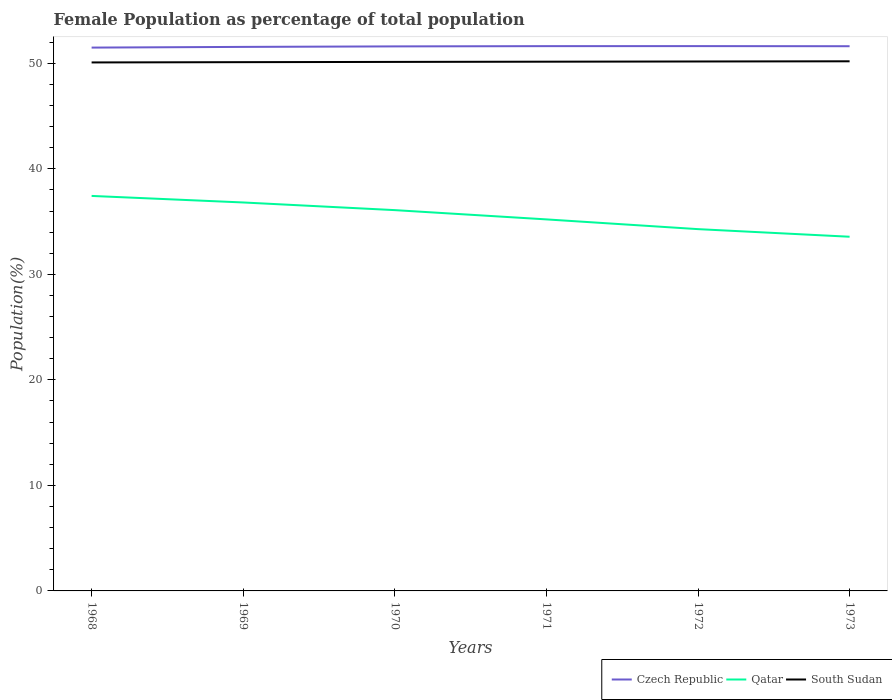Is the number of lines equal to the number of legend labels?
Provide a short and direct response. Yes. Across all years, what is the maximum female population in in South Sudan?
Your answer should be very brief. 50.08. In which year was the female population in in Qatar maximum?
Your response must be concise. 1973. What is the total female population in in Czech Republic in the graph?
Give a very brief answer. -0.07. What is the difference between the highest and the second highest female population in in South Sudan?
Ensure brevity in your answer.  0.11. How many years are there in the graph?
Offer a very short reply. 6. What is the difference between two consecutive major ticks on the Y-axis?
Keep it short and to the point. 10. Does the graph contain grids?
Your answer should be very brief. No. How many legend labels are there?
Make the answer very short. 3. How are the legend labels stacked?
Your response must be concise. Horizontal. What is the title of the graph?
Keep it short and to the point. Female Population as percentage of total population. Does "Ghana" appear as one of the legend labels in the graph?
Provide a short and direct response. No. What is the label or title of the X-axis?
Ensure brevity in your answer.  Years. What is the label or title of the Y-axis?
Offer a terse response. Population(%). What is the Population(%) of Czech Republic in 1968?
Ensure brevity in your answer.  51.49. What is the Population(%) in Qatar in 1968?
Give a very brief answer. 37.43. What is the Population(%) of South Sudan in 1968?
Ensure brevity in your answer.  50.08. What is the Population(%) in Czech Republic in 1969?
Give a very brief answer. 51.55. What is the Population(%) in Qatar in 1969?
Give a very brief answer. 36.81. What is the Population(%) of South Sudan in 1969?
Your answer should be very brief. 50.11. What is the Population(%) in Czech Republic in 1970?
Give a very brief answer. 51.6. What is the Population(%) of Qatar in 1970?
Keep it short and to the point. 36.09. What is the Population(%) of South Sudan in 1970?
Your answer should be compact. 50.13. What is the Population(%) in Czech Republic in 1971?
Give a very brief answer. 51.62. What is the Population(%) of Qatar in 1971?
Offer a terse response. 35.21. What is the Population(%) of South Sudan in 1971?
Your answer should be very brief. 50.15. What is the Population(%) of Czech Republic in 1972?
Keep it short and to the point. 51.63. What is the Population(%) of Qatar in 1972?
Provide a short and direct response. 34.28. What is the Population(%) of South Sudan in 1972?
Your answer should be very brief. 50.17. What is the Population(%) of Czech Republic in 1973?
Your answer should be very brief. 51.62. What is the Population(%) in Qatar in 1973?
Your answer should be compact. 33.56. What is the Population(%) of South Sudan in 1973?
Ensure brevity in your answer.  50.19. Across all years, what is the maximum Population(%) in Czech Republic?
Your answer should be very brief. 51.63. Across all years, what is the maximum Population(%) in Qatar?
Provide a succinct answer. 37.43. Across all years, what is the maximum Population(%) in South Sudan?
Provide a short and direct response. 50.19. Across all years, what is the minimum Population(%) of Czech Republic?
Give a very brief answer. 51.49. Across all years, what is the minimum Population(%) of Qatar?
Provide a succinct answer. 33.56. Across all years, what is the minimum Population(%) in South Sudan?
Give a very brief answer. 50.08. What is the total Population(%) in Czech Republic in the graph?
Offer a terse response. 309.52. What is the total Population(%) in Qatar in the graph?
Make the answer very short. 213.38. What is the total Population(%) of South Sudan in the graph?
Provide a short and direct response. 300.83. What is the difference between the Population(%) of Czech Republic in 1968 and that in 1969?
Ensure brevity in your answer.  -0.07. What is the difference between the Population(%) in Qatar in 1968 and that in 1969?
Offer a terse response. 0.62. What is the difference between the Population(%) of South Sudan in 1968 and that in 1969?
Offer a terse response. -0.03. What is the difference between the Population(%) of Czech Republic in 1968 and that in 1970?
Provide a succinct answer. -0.11. What is the difference between the Population(%) of Qatar in 1968 and that in 1970?
Provide a short and direct response. 1.35. What is the difference between the Population(%) of South Sudan in 1968 and that in 1970?
Your answer should be compact. -0.05. What is the difference between the Population(%) of Czech Republic in 1968 and that in 1971?
Provide a succinct answer. -0.14. What is the difference between the Population(%) in Qatar in 1968 and that in 1971?
Give a very brief answer. 2.22. What is the difference between the Population(%) of South Sudan in 1968 and that in 1971?
Keep it short and to the point. -0.07. What is the difference between the Population(%) of Czech Republic in 1968 and that in 1972?
Ensure brevity in your answer.  -0.14. What is the difference between the Population(%) of Qatar in 1968 and that in 1972?
Your answer should be very brief. 3.15. What is the difference between the Population(%) of South Sudan in 1968 and that in 1972?
Your answer should be compact. -0.09. What is the difference between the Population(%) in Czech Republic in 1968 and that in 1973?
Your response must be concise. -0.13. What is the difference between the Population(%) in Qatar in 1968 and that in 1973?
Your answer should be compact. 3.87. What is the difference between the Population(%) in South Sudan in 1968 and that in 1973?
Keep it short and to the point. -0.11. What is the difference between the Population(%) of Czech Republic in 1969 and that in 1970?
Your answer should be compact. -0.05. What is the difference between the Population(%) in Qatar in 1969 and that in 1970?
Ensure brevity in your answer.  0.73. What is the difference between the Population(%) of South Sudan in 1969 and that in 1970?
Offer a terse response. -0.02. What is the difference between the Population(%) of Czech Republic in 1969 and that in 1971?
Offer a terse response. -0.07. What is the difference between the Population(%) in Qatar in 1969 and that in 1971?
Offer a terse response. 1.6. What is the difference between the Population(%) of South Sudan in 1969 and that in 1971?
Offer a terse response. -0.04. What is the difference between the Population(%) in Czech Republic in 1969 and that in 1972?
Your answer should be very brief. -0.07. What is the difference between the Population(%) of Qatar in 1969 and that in 1972?
Offer a very short reply. 2.53. What is the difference between the Population(%) of South Sudan in 1969 and that in 1972?
Your response must be concise. -0.06. What is the difference between the Population(%) in Czech Republic in 1969 and that in 1973?
Provide a succinct answer. -0.06. What is the difference between the Population(%) in Qatar in 1969 and that in 1973?
Give a very brief answer. 3.25. What is the difference between the Population(%) in South Sudan in 1969 and that in 1973?
Your response must be concise. -0.08. What is the difference between the Population(%) of Czech Republic in 1970 and that in 1971?
Offer a very short reply. -0.02. What is the difference between the Population(%) in Qatar in 1970 and that in 1971?
Keep it short and to the point. 0.88. What is the difference between the Population(%) in South Sudan in 1970 and that in 1971?
Offer a terse response. -0.02. What is the difference between the Population(%) of Czech Republic in 1970 and that in 1972?
Your answer should be very brief. -0.03. What is the difference between the Population(%) in Qatar in 1970 and that in 1972?
Make the answer very short. 1.8. What is the difference between the Population(%) in South Sudan in 1970 and that in 1972?
Keep it short and to the point. -0.04. What is the difference between the Population(%) in Czech Republic in 1970 and that in 1973?
Give a very brief answer. -0.02. What is the difference between the Population(%) of Qatar in 1970 and that in 1973?
Offer a terse response. 2.52. What is the difference between the Population(%) in South Sudan in 1970 and that in 1973?
Keep it short and to the point. -0.06. What is the difference between the Population(%) of Czech Republic in 1971 and that in 1972?
Offer a very short reply. -0. What is the difference between the Population(%) in Qatar in 1971 and that in 1972?
Make the answer very short. 0.92. What is the difference between the Population(%) of South Sudan in 1971 and that in 1972?
Offer a terse response. -0.02. What is the difference between the Population(%) in Czech Republic in 1971 and that in 1973?
Your answer should be very brief. 0.01. What is the difference between the Population(%) of Qatar in 1971 and that in 1973?
Offer a very short reply. 1.64. What is the difference between the Population(%) of South Sudan in 1971 and that in 1973?
Provide a short and direct response. -0.04. What is the difference between the Population(%) in Czech Republic in 1972 and that in 1973?
Provide a short and direct response. 0.01. What is the difference between the Population(%) of Qatar in 1972 and that in 1973?
Offer a very short reply. 0.72. What is the difference between the Population(%) in South Sudan in 1972 and that in 1973?
Give a very brief answer. -0.02. What is the difference between the Population(%) of Czech Republic in 1968 and the Population(%) of Qatar in 1969?
Your answer should be very brief. 14.68. What is the difference between the Population(%) in Czech Republic in 1968 and the Population(%) in South Sudan in 1969?
Provide a succinct answer. 1.38. What is the difference between the Population(%) of Qatar in 1968 and the Population(%) of South Sudan in 1969?
Make the answer very short. -12.68. What is the difference between the Population(%) of Czech Republic in 1968 and the Population(%) of Qatar in 1970?
Your response must be concise. 15.4. What is the difference between the Population(%) of Czech Republic in 1968 and the Population(%) of South Sudan in 1970?
Keep it short and to the point. 1.36. What is the difference between the Population(%) of Czech Republic in 1968 and the Population(%) of Qatar in 1971?
Your answer should be very brief. 16.28. What is the difference between the Population(%) of Czech Republic in 1968 and the Population(%) of South Sudan in 1971?
Provide a succinct answer. 1.34. What is the difference between the Population(%) in Qatar in 1968 and the Population(%) in South Sudan in 1971?
Provide a short and direct response. -12.72. What is the difference between the Population(%) in Czech Republic in 1968 and the Population(%) in Qatar in 1972?
Ensure brevity in your answer.  17.2. What is the difference between the Population(%) in Czech Republic in 1968 and the Population(%) in South Sudan in 1972?
Ensure brevity in your answer.  1.32. What is the difference between the Population(%) in Qatar in 1968 and the Population(%) in South Sudan in 1972?
Make the answer very short. -12.74. What is the difference between the Population(%) in Czech Republic in 1968 and the Population(%) in Qatar in 1973?
Make the answer very short. 17.92. What is the difference between the Population(%) in Czech Republic in 1968 and the Population(%) in South Sudan in 1973?
Ensure brevity in your answer.  1.3. What is the difference between the Population(%) in Qatar in 1968 and the Population(%) in South Sudan in 1973?
Provide a short and direct response. -12.76. What is the difference between the Population(%) of Czech Republic in 1969 and the Population(%) of Qatar in 1970?
Your response must be concise. 15.47. What is the difference between the Population(%) of Czech Republic in 1969 and the Population(%) of South Sudan in 1970?
Give a very brief answer. 1.42. What is the difference between the Population(%) of Qatar in 1969 and the Population(%) of South Sudan in 1970?
Ensure brevity in your answer.  -13.32. What is the difference between the Population(%) of Czech Republic in 1969 and the Population(%) of Qatar in 1971?
Your answer should be very brief. 16.35. What is the difference between the Population(%) in Czech Republic in 1969 and the Population(%) in South Sudan in 1971?
Provide a succinct answer. 1.4. What is the difference between the Population(%) in Qatar in 1969 and the Population(%) in South Sudan in 1971?
Your answer should be very brief. -13.34. What is the difference between the Population(%) of Czech Republic in 1969 and the Population(%) of Qatar in 1972?
Provide a succinct answer. 17.27. What is the difference between the Population(%) in Czech Republic in 1969 and the Population(%) in South Sudan in 1972?
Provide a short and direct response. 1.38. What is the difference between the Population(%) of Qatar in 1969 and the Population(%) of South Sudan in 1972?
Your response must be concise. -13.36. What is the difference between the Population(%) of Czech Republic in 1969 and the Population(%) of Qatar in 1973?
Provide a succinct answer. 17.99. What is the difference between the Population(%) in Czech Republic in 1969 and the Population(%) in South Sudan in 1973?
Your answer should be compact. 1.37. What is the difference between the Population(%) of Qatar in 1969 and the Population(%) of South Sudan in 1973?
Your answer should be compact. -13.38. What is the difference between the Population(%) in Czech Republic in 1970 and the Population(%) in Qatar in 1971?
Your response must be concise. 16.39. What is the difference between the Population(%) in Czech Republic in 1970 and the Population(%) in South Sudan in 1971?
Make the answer very short. 1.45. What is the difference between the Population(%) of Qatar in 1970 and the Population(%) of South Sudan in 1971?
Provide a succinct answer. -14.07. What is the difference between the Population(%) in Czech Republic in 1970 and the Population(%) in Qatar in 1972?
Your answer should be compact. 17.32. What is the difference between the Population(%) in Czech Republic in 1970 and the Population(%) in South Sudan in 1972?
Make the answer very short. 1.43. What is the difference between the Population(%) in Qatar in 1970 and the Population(%) in South Sudan in 1972?
Make the answer very short. -14.09. What is the difference between the Population(%) of Czech Republic in 1970 and the Population(%) of Qatar in 1973?
Offer a very short reply. 18.04. What is the difference between the Population(%) in Czech Republic in 1970 and the Population(%) in South Sudan in 1973?
Make the answer very short. 1.41. What is the difference between the Population(%) in Qatar in 1970 and the Population(%) in South Sudan in 1973?
Your response must be concise. -14.1. What is the difference between the Population(%) in Czech Republic in 1971 and the Population(%) in Qatar in 1972?
Provide a succinct answer. 17.34. What is the difference between the Population(%) of Czech Republic in 1971 and the Population(%) of South Sudan in 1972?
Your answer should be very brief. 1.45. What is the difference between the Population(%) in Qatar in 1971 and the Population(%) in South Sudan in 1972?
Your answer should be very brief. -14.96. What is the difference between the Population(%) of Czech Republic in 1971 and the Population(%) of Qatar in 1973?
Offer a very short reply. 18.06. What is the difference between the Population(%) in Czech Republic in 1971 and the Population(%) in South Sudan in 1973?
Keep it short and to the point. 1.44. What is the difference between the Population(%) of Qatar in 1971 and the Population(%) of South Sudan in 1973?
Your answer should be compact. -14.98. What is the difference between the Population(%) of Czech Republic in 1972 and the Population(%) of Qatar in 1973?
Offer a terse response. 18.06. What is the difference between the Population(%) in Czech Republic in 1972 and the Population(%) in South Sudan in 1973?
Your answer should be very brief. 1.44. What is the difference between the Population(%) in Qatar in 1972 and the Population(%) in South Sudan in 1973?
Your answer should be very brief. -15.9. What is the average Population(%) of Czech Republic per year?
Provide a short and direct response. 51.59. What is the average Population(%) of Qatar per year?
Your answer should be compact. 35.56. What is the average Population(%) of South Sudan per year?
Ensure brevity in your answer.  50.14. In the year 1968, what is the difference between the Population(%) of Czech Republic and Population(%) of Qatar?
Offer a terse response. 14.06. In the year 1968, what is the difference between the Population(%) in Czech Republic and Population(%) in South Sudan?
Keep it short and to the point. 1.41. In the year 1968, what is the difference between the Population(%) of Qatar and Population(%) of South Sudan?
Your answer should be very brief. -12.65. In the year 1969, what is the difference between the Population(%) of Czech Republic and Population(%) of Qatar?
Make the answer very short. 14.74. In the year 1969, what is the difference between the Population(%) in Czech Republic and Population(%) in South Sudan?
Make the answer very short. 1.45. In the year 1969, what is the difference between the Population(%) of Qatar and Population(%) of South Sudan?
Offer a terse response. -13.3. In the year 1970, what is the difference between the Population(%) in Czech Republic and Population(%) in Qatar?
Offer a terse response. 15.52. In the year 1970, what is the difference between the Population(%) of Czech Republic and Population(%) of South Sudan?
Your response must be concise. 1.47. In the year 1970, what is the difference between the Population(%) of Qatar and Population(%) of South Sudan?
Your answer should be compact. -14.05. In the year 1971, what is the difference between the Population(%) of Czech Republic and Population(%) of Qatar?
Provide a succinct answer. 16.42. In the year 1971, what is the difference between the Population(%) in Czech Republic and Population(%) in South Sudan?
Provide a short and direct response. 1.47. In the year 1971, what is the difference between the Population(%) in Qatar and Population(%) in South Sudan?
Provide a succinct answer. -14.95. In the year 1972, what is the difference between the Population(%) in Czech Republic and Population(%) in Qatar?
Offer a terse response. 17.34. In the year 1972, what is the difference between the Population(%) of Czech Republic and Population(%) of South Sudan?
Your answer should be compact. 1.46. In the year 1972, what is the difference between the Population(%) of Qatar and Population(%) of South Sudan?
Ensure brevity in your answer.  -15.89. In the year 1973, what is the difference between the Population(%) of Czech Republic and Population(%) of Qatar?
Give a very brief answer. 18.05. In the year 1973, what is the difference between the Population(%) of Czech Republic and Population(%) of South Sudan?
Offer a very short reply. 1.43. In the year 1973, what is the difference between the Population(%) of Qatar and Population(%) of South Sudan?
Your response must be concise. -16.62. What is the ratio of the Population(%) of Czech Republic in 1968 to that in 1969?
Make the answer very short. 1. What is the ratio of the Population(%) in Qatar in 1968 to that in 1969?
Your answer should be compact. 1.02. What is the ratio of the Population(%) in South Sudan in 1968 to that in 1969?
Offer a terse response. 1. What is the ratio of the Population(%) in Qatar in 1968 to that in 1970?
Offer a very short reply. 1.04. What is the ratio of the Population(%) of Czech Republic in 1968 to that in 1971?
Offer a terse response. 1. What is the ratio of the Population(%) of Qatar in 1968 to that in 1971?
Provide a succinct answer. 1.06. What is the ratio of the Population(%) of Qatar in 1968 to that in 1972?
Your answer should be compact. 1.09. What is the ratio of the Population(%) in Czech Republic in 1968 to that in 1973?
Provide a succinct answer. 1. What is the ratio of the Population(%) in Qatar in 1968 to that in 1973?
Make the answer very short. 1.12. What is the ratio of the Population(%) of South Sudan in 1968 to that in 1973?
Offer a terse response. 1. What is the ratio of the Population(%) of Czech Republic in 1969 to that in 1970?
Give a very brief answer. 1. What is the ratio of the Population(%) of Qatar in 1969 to that in 1970?
Make the answer very short. 1.02. What is the ratio of the Population(%) in South Sudan in 1969 to that in 1970?
Your response must be concise. 1. What is the ratio of the Population(%) in Qatar in 1969 to that in 1971?
Provide a succinct answer. 1.05. What is the ratio of the Population(%) of South Sudan in 1969 to that in 1971?
Give a very brief answer. 1. What is the ratio of the Population(%) in Czech Republic in 1969 to that in 1972?
Ensure brevity in your answer.  1. What is the ratio of the Population(%) of Qatar in 1969 to that in 1972?
Ensure brevity in your answer.  1.07. What is the ratio of the Population(%) in South Sudan in 1969 to that in 1972?
Provide a short and direct response. 1. What is the ratio of the Population(%) of Czech Republic in 1969 to that in 1973?
Make the answer very short. 1. What is the ratio of the Population(%) in Qatar in 1969 to that in 1973?
Provide a succinct answer. 1.1. What is the ratio of the Population(%) in Qatar in 1970 to that in 1971?
Your response must be concise. 1.02. What is the ratio of the Population(%) of Qatar in 1970 to that in 1972?
Offer a terse response. 1.05. What is the ratio of the Population(%) in Czech Republic in 1970 to that in 1973?
Your answer should be very brief. 1. What is the ratio of the Population(%) of Qatar in 1970 to that in 1973?
Make the answer very short. 1.08. What is the ratio of the Population(%) of South Sudan in 1970 to that in 1973?
Keep it short and to the point. 1. What is the ratio of the Population(%) in Qatar in 1971 to that in 1972?
Keep it short and to the point. 1.03. What is the ratio of the Population(%) in Czech Republic in 1971 to that in 1973?
Offer a terse response. 1. What is the ratio of the Population(%) of Qatar in 1971 to that in 1973?
Offer a very short reply. 1.05. What is the ratio of the Population(%) in Czech Republic in 1972 to that in 1973?
Your response must be concise. 1. What is the ratio of the Population(%) of Qatar in 1972 to that in 1973?
Your response must be concise. 1.02. What is the difference between the highest and the second highest Population(%) in Czech Republic?
Your response must be concise. 0. What is the difference between the highest and the second highest Population(%) in Qatar?
Provide a short and direct response. 0.62. What is the difference between the highest and the second highest Population(%) of South Sudan?
Give a very brief answer. 0.02. What is the difference between the highest and the lowest Population(%) in Czech Republic?
Offer a terse response. 0.14. What is the difference between the highest and the lowest Population(%) in Qatar?
Provide a short and direct response. 3.87. What is the difference between the highest and the lowest Population(%) in South Sudan?
Offer a very short reply. 0.11. 